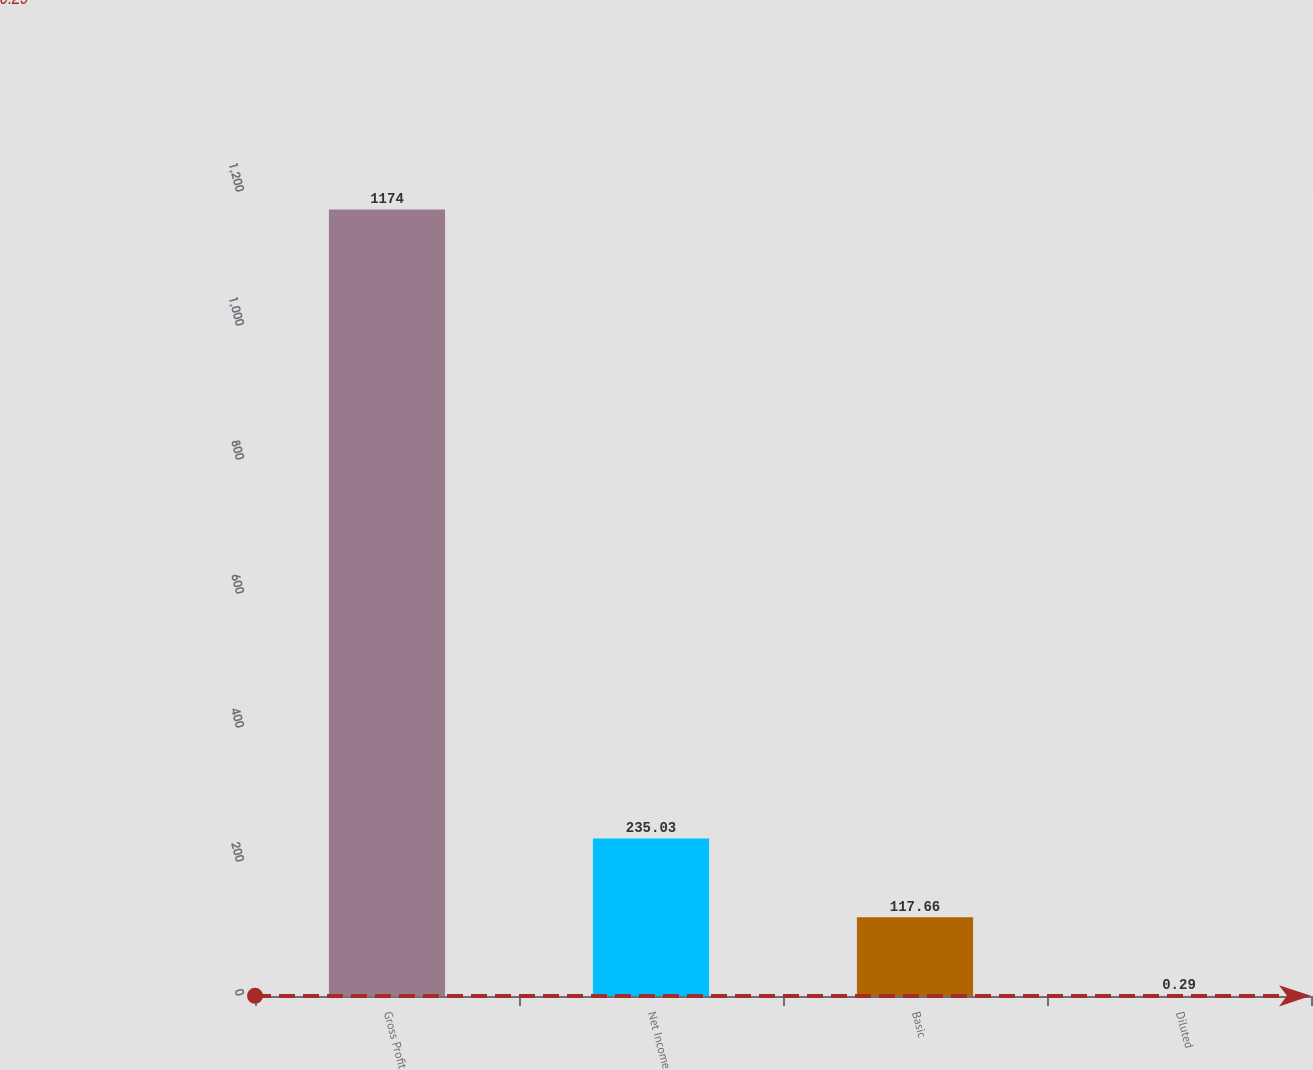Convert chart to OTSL. <chart><loc_0><loc_0><loc_500><loc_500><bar_chart><fcel>Gross Profit<fcel>Net Income<fcel>Basic<fcel>Diluted<nl><fcel>1174<fcel>235.03<fcel>117.66<fcel>0.29<nl></chart> 